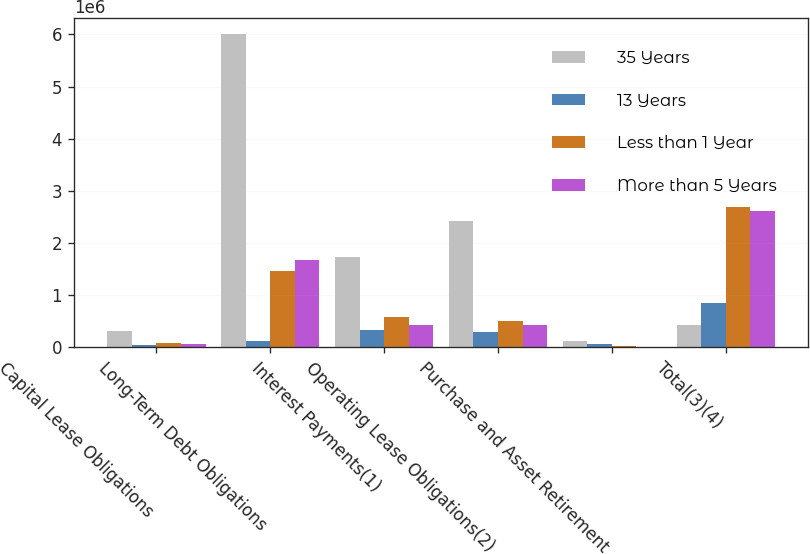Convert chart to OTSL. <chart><loc_0><loc_0><loc_500><loc_500><stacked_bar_chart><ecel><fcel>Capital Lease Obligations<fcel>Long-Term Debt Obligations<fcel>Interest Payments(1)<fcel>Operating Lease Obligations(2)<fcel>Purchase and Asset Retirement<fcel>Total(3)(4)<nl><fcel>35 Years<fcel>309860<fcel>6.01098e+06<fcel>1.73461e+06<fcel>2.41462e+06<fcel>118268<fcel>432312<nl><fcel>13 Years<fcel>52640<fcel>120335<fcel>325079<fcel>294103<fcel>58378<fcel>850535<nl><fcel>Less than 1 Year<fcel>85519<fcel>1.4719e+06<fcel>590170<fcel>511789<fcel>29975<fcel>2.68935e+06<nl><fcel>More than 5 Years<fcel>70405<fcel>1.6794e+06<fcel>432312<fcel>433715<fcel>2960<fcel>2.61879e+06<nl></chart> 